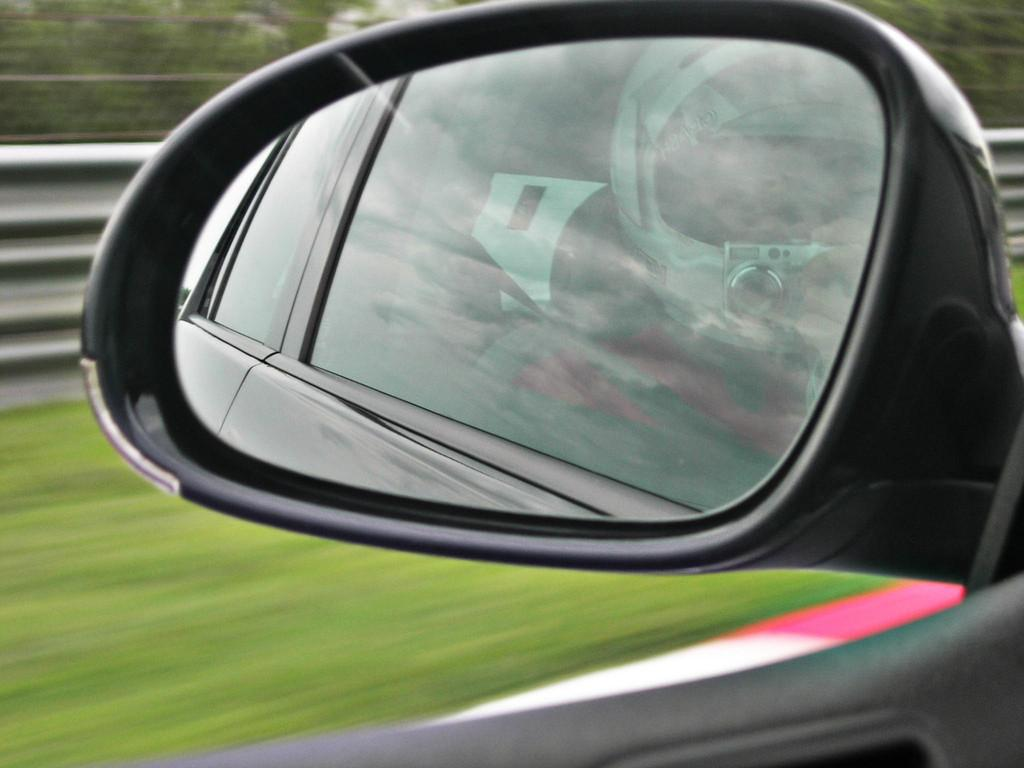What is the main subject of the image? The main subject of the image is a car mirror. What does the car mirror reflect in the image? The car mirror reflects a person with a helmet in the image. What is the person holding in the image? The person is holding a camera in the image. What type of natural environment is visible in the background of the image? There is grass, trees, and an iron sheet visible in the background of the image. What plot of land is being discussed by the committee in the image? There is no committee or plot of land present in the image; it features a car mirror reflecting a person with a helmet. How is the person measuring the distance between the trees in the image? There is no person measuring the distance between trees in the image; the person is holding a camera. 